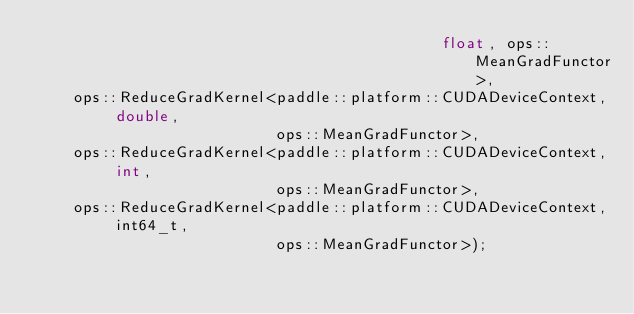<code> <loc_0><loc_0><loc_500><loc_500><_Cuda_>                                            float, ops::MeanGradFunctor>,
    ops::ReduceGradKernel<paddle::platform::CUDADeviceContext, double,
                          ops::MeanGradFunctor>,
    ops::ReduceGradKernel<paddle::platform::CUDADeviceContext, int,
                          ops::MeanGradFunctor>,
    ops::ReduceGradKernel<paddle::platform::CUDADeviceContext, int64_t,
                          ops::MeanGradFunctor>);
</code> 